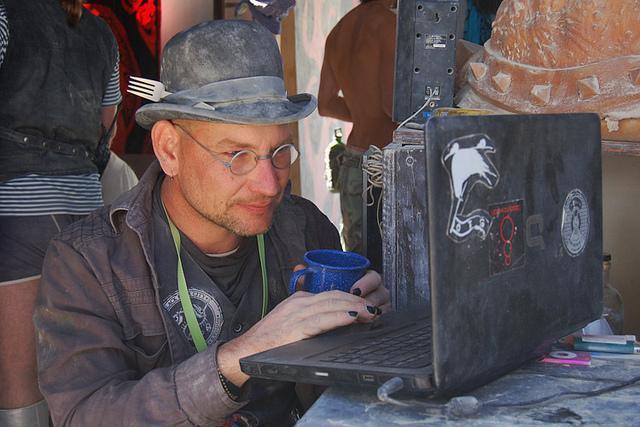How many people are there?
Give a very brief answer. 3. How many solid black cats on the chair?
Give a very brief answer. 0. 